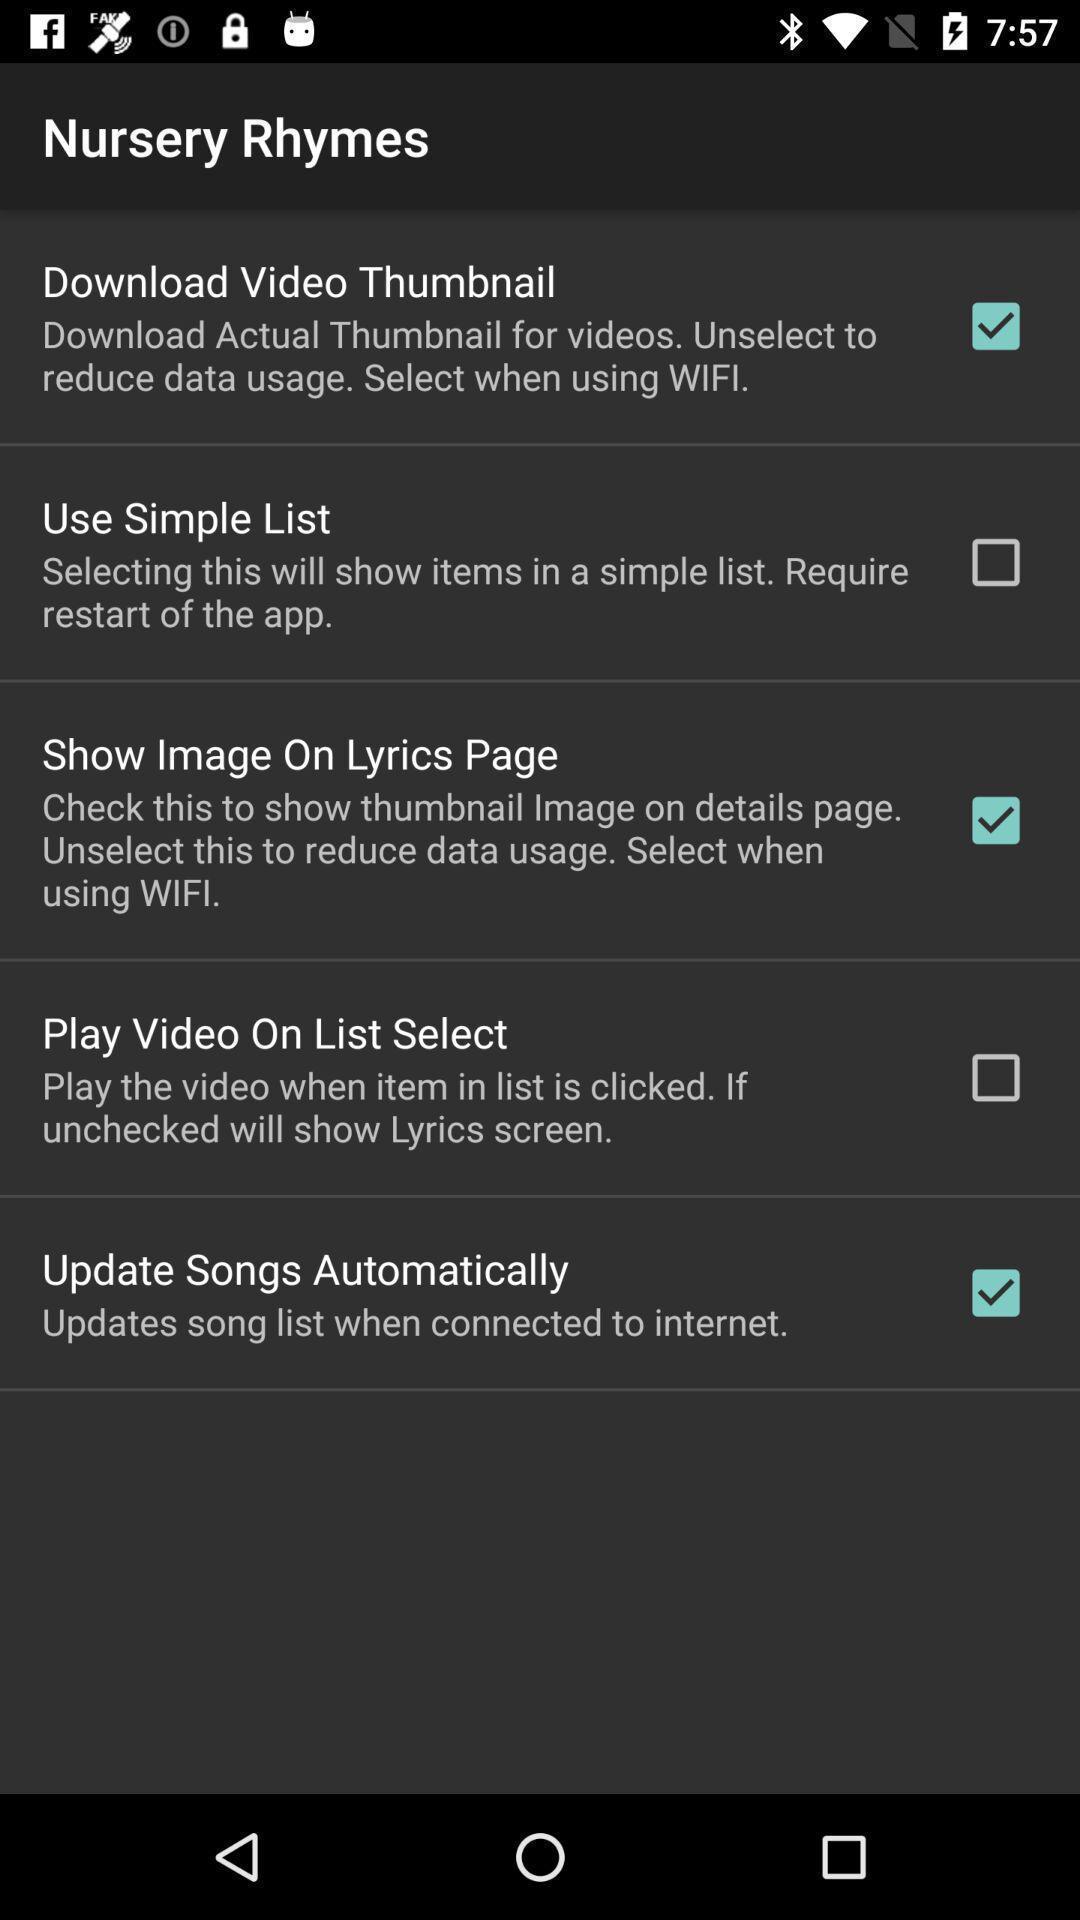Tell me about the visual elements in this screen capture. Screen page displaying various settings options. 